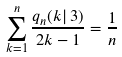<formula> <loc_0><loc_0><loc_500><loc_500>\sum _ { k = 1 } ^ { n } \frac { q _ { n } ( k | \, 3 ) } { 2 k - 1 } = \frac { 1 } { n }</formula> 